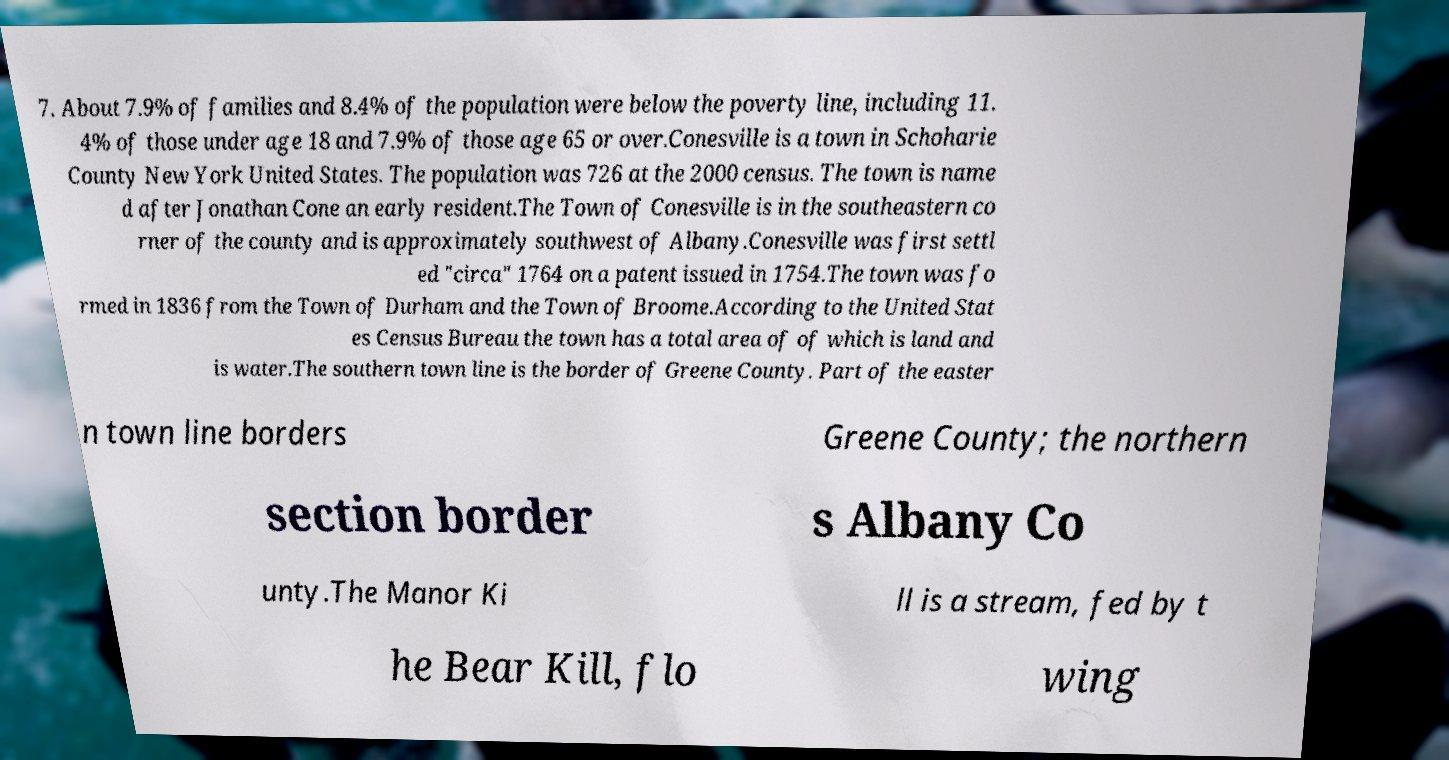I need the written content from this picture converted into text. Can you do that? 7. About 7.9% of families and 8.4% of the population were below the poverty line, including 11. 4% of those under age 18 and 7.9% of those age 65 or over.Conesville is a town in Schoharie County New York United States. The population was 726 at the 2000 census. The town is name d after Jonathan Cone an early resident.The Town of Conesville is in the southeastern co rner of the county and is approximately southwest of Albany.Conesville was first settl ed "circa" 1764 on a patent issued in 1754.The town was fo rmed in 1836 from the Town of Durham and the Town of Broome.According to the United Stat es Census Bureau the town has a total area of of which is land and is water.The southern town line is the border of Greene County. Part of the easter n town line borders Greene County; the northern section border s Albany Co unty.The Manor Ki ll is a stream, fed by t he Bear Kill, flo wing 